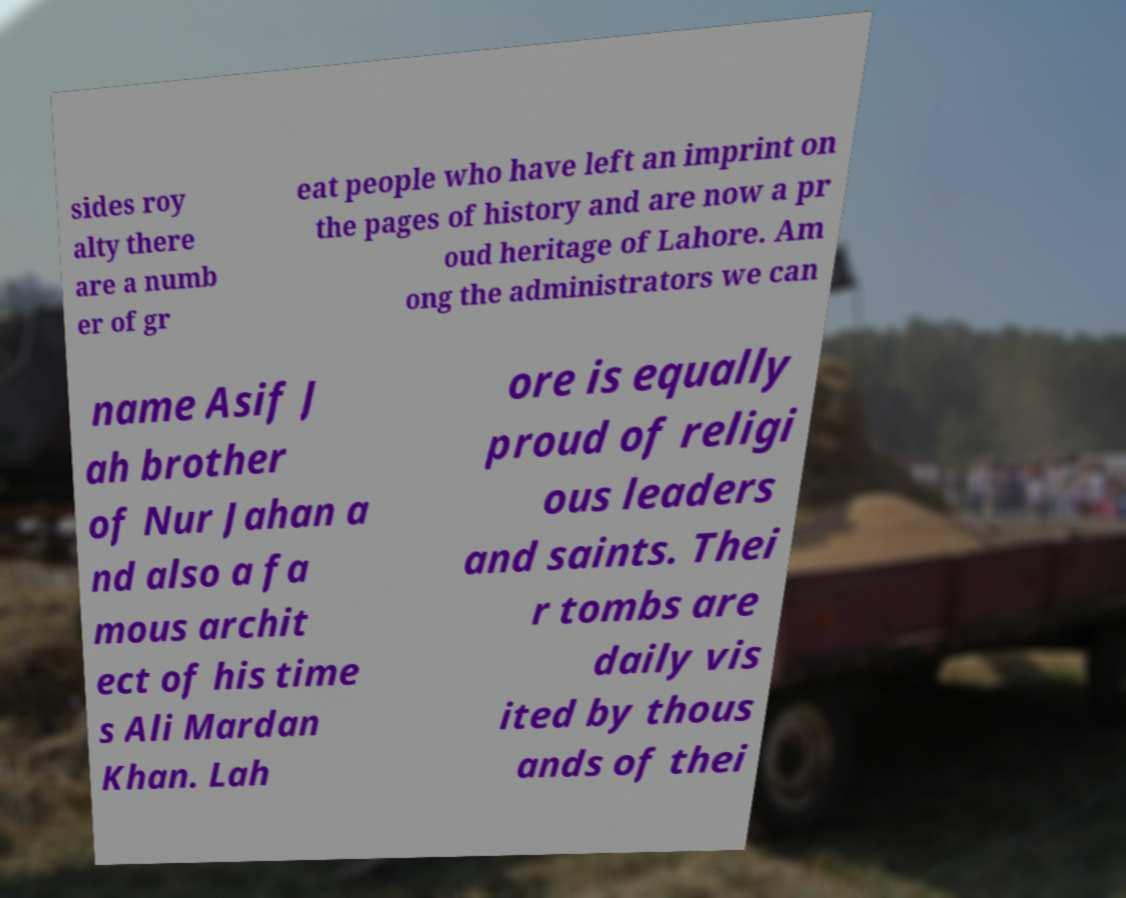For documentation purposes, I need the text within this image transcribed. Could you provide that? sides roy alty there are a numb er of gr eat people who have left an imprint on the pages of history and are now a pr oud heritage of Lahore. Am ong the administrators we can name Asif J ah brother of Nur Jahan a nd also a fa mous archit ect of his time s Ali Mardan Khan. Lah ore is equally proud of religi ous leaders and saints. Thei r tombs are daily vis ited by thous ands of thei 